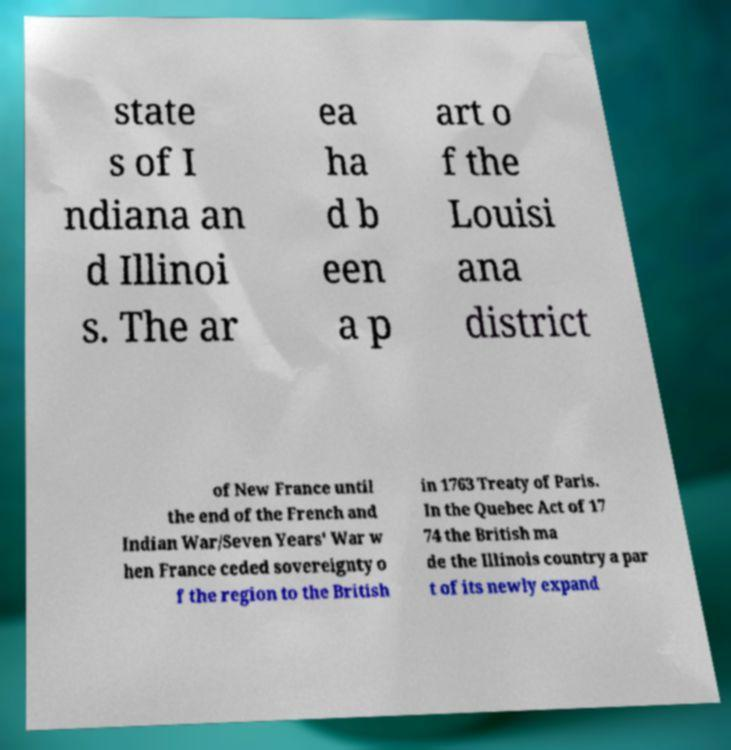Can you accurately transcribe the text from the provided image for me? state s of I ndiana an d Illinoi s. The ar ea ha d b een a p art o f the Louisi ana district of New France until the end of the French and Indian War/Seven Years' War w hen France ceded sovereignty o f the region to the British in 1763 Treaty of Paris. In the Quebec Act of 17 74 the British ma de the Illinois country a par t of its newly expand 